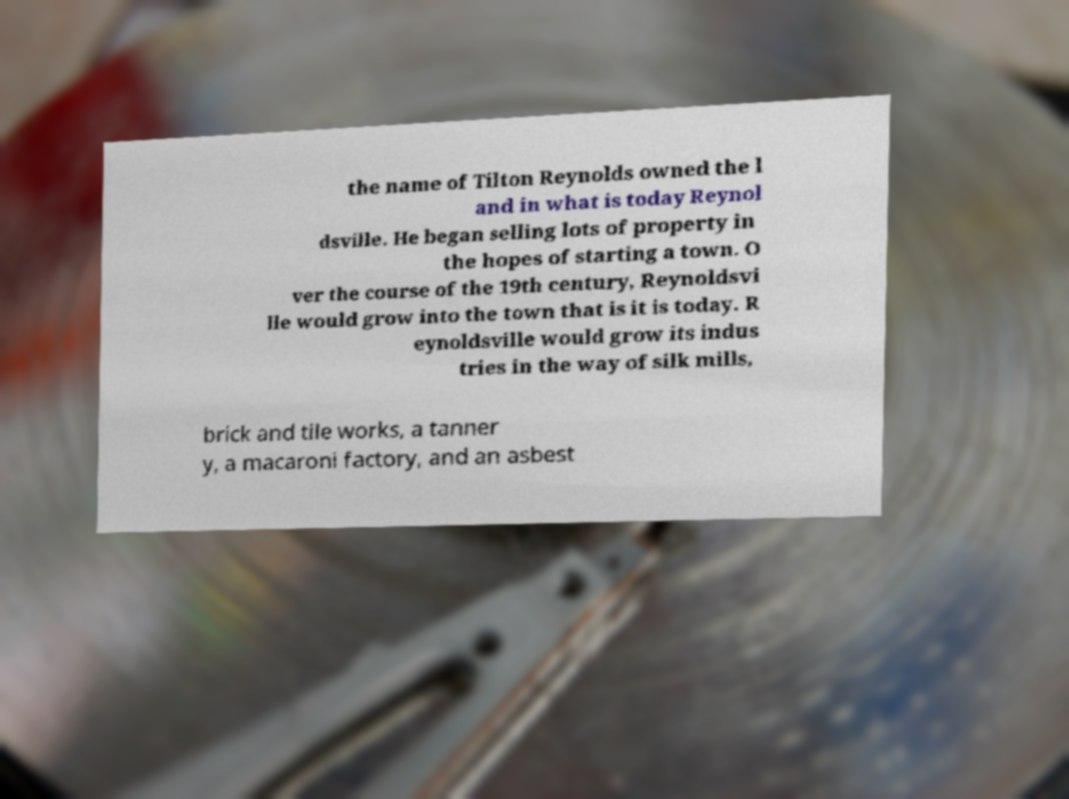For documentation purposes, I need the text within this image transcribed. Could you provide that? the name of Tilton Reynolds owned the l and in what is today Reynol dsville. He began selling lots of property in the hopes of starting a town. O ver the course of the 19th century, Reynoldsvi lle would grow into the town that is it is today. R eynoldsville would grow its indus tries in the way of silk mills, brick and tile works, a tanner y, a macaroni factory, and an asbest 